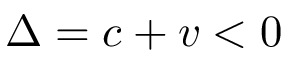Convert formula to latex. <formula><loc_0><loc_0><loc_500><loc_500>\Delta = c + v < 0</formula> 